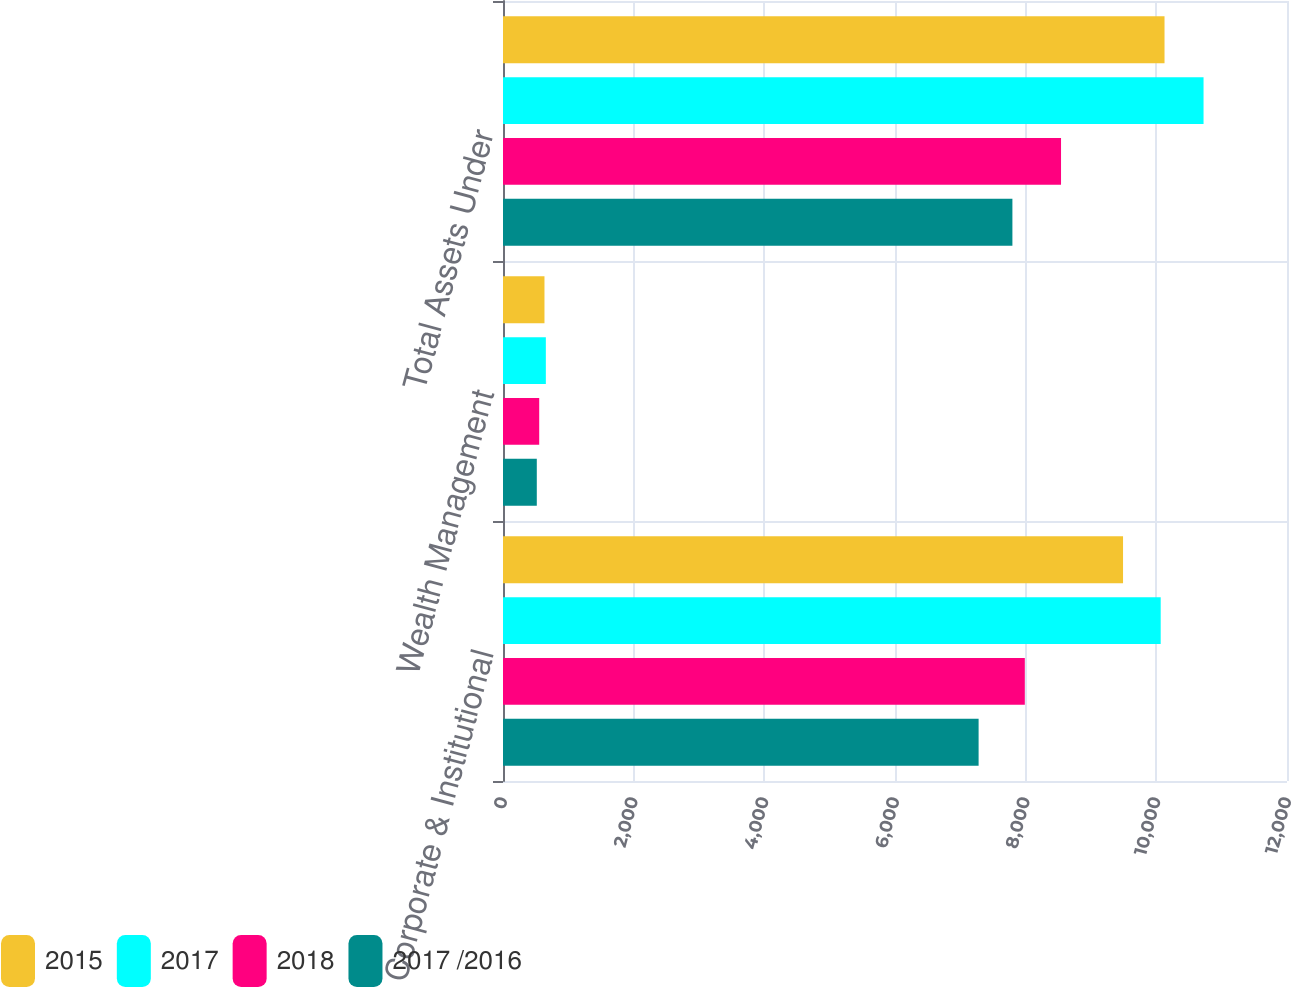<chart> <loc_0><loc_0><loc_500><loc_500><stacked_bar_chart><ecel><fcel>Corporate & Institutional<fcel>Wealth Management<fcel>Total Assets Under<nl><fcel>2015<fcel>9490.5<fcel>634.8<fcel>10125.3<nl><fcel>2017<fcel>10066.8<fcel>655.8<fcel>10722.6<nl><fcel>2018<fcel>7987<fcel>554.3<fcel>8541.3<nl><fcel>2017 /2016<fcel>7279.7<fcel>517.3<fcel>7797<nl></chart> 